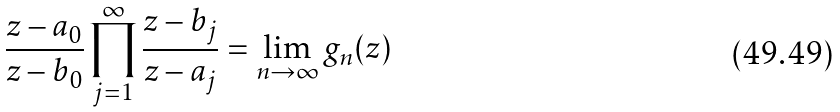<formula> <loc_0><loc_0><loc_500><loc_500>\frac { z - a _ { 0 } } { z - b _ { 0 } } \prod _ { j = 1 } ^ { \infty } \frac { z - b _ { j } } { z - a _ { j } } = \lim _ { n \to \infty } g _ { n } ( z )</formula> 